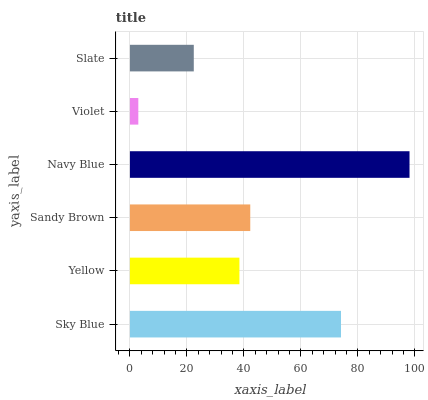Is Violet the minimum?
Answer yes or no. Yes. Is Navy Blue the maximum?
Answer yes or no. Yes. Is Yellow the minimum?
Answer yes or no. No. Is Yellow the maximum?
Answer yes or no. No. Is Sky Blue greater than Yellow?
Answer yes or no. Yes. Is Yellow less than Sky Blue?
Answer yes or no. Yes. Is Yellow greater than Sky Blue?
Answer yes or no. No. Is Sky Blue less than Yellow?
Answer yes or no. No. Is Sandy Brown the high median?
Answer yes or no. Yes. Is Yellow the low median?
Answer yes or no. Yes. Is Violet the high median?
Answer yes or no. No. Is Sky Blue the low median?
Answer yes or no. No. 